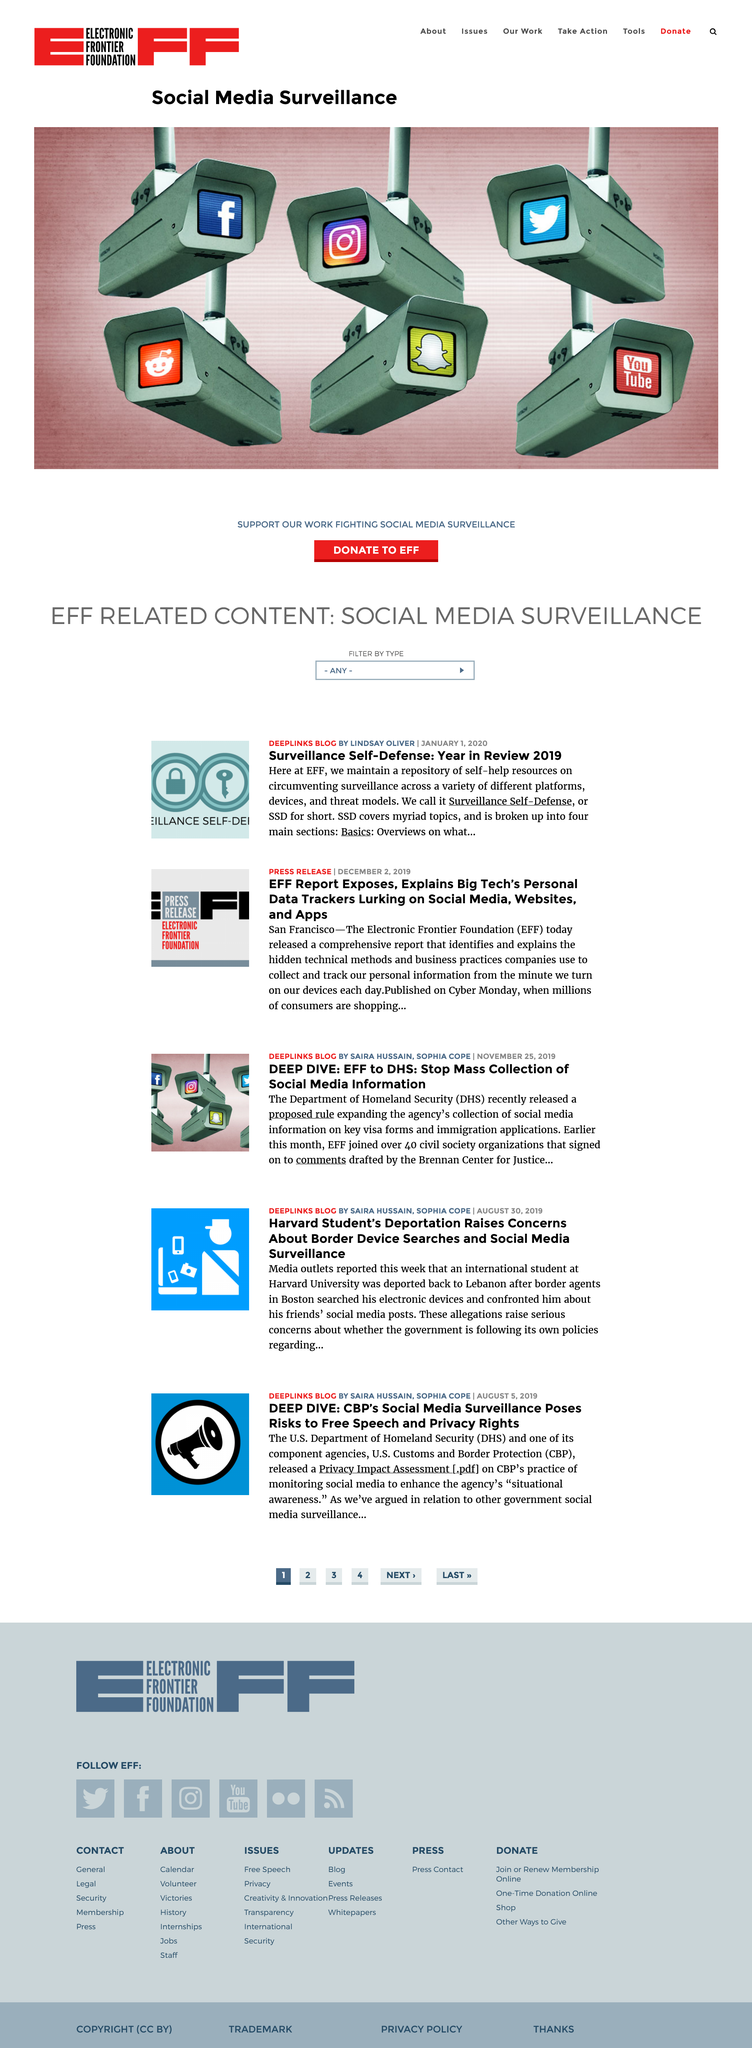Indicate a few pertinent items in this graphic. The Department of Homeland Security recently proposed a rule to expand the agency's collection of social media information from key visa forms and immigration applications. Surveillance Self-Defense is an abbreviation commonly known as SSD, which is a comprehensive guide designed to help individuals and organizations stay informed and protected from the latest surveillance threats. The article "Surveillance Self-Defense: Year in Review 2019" was written by Lindsay Oliver. 